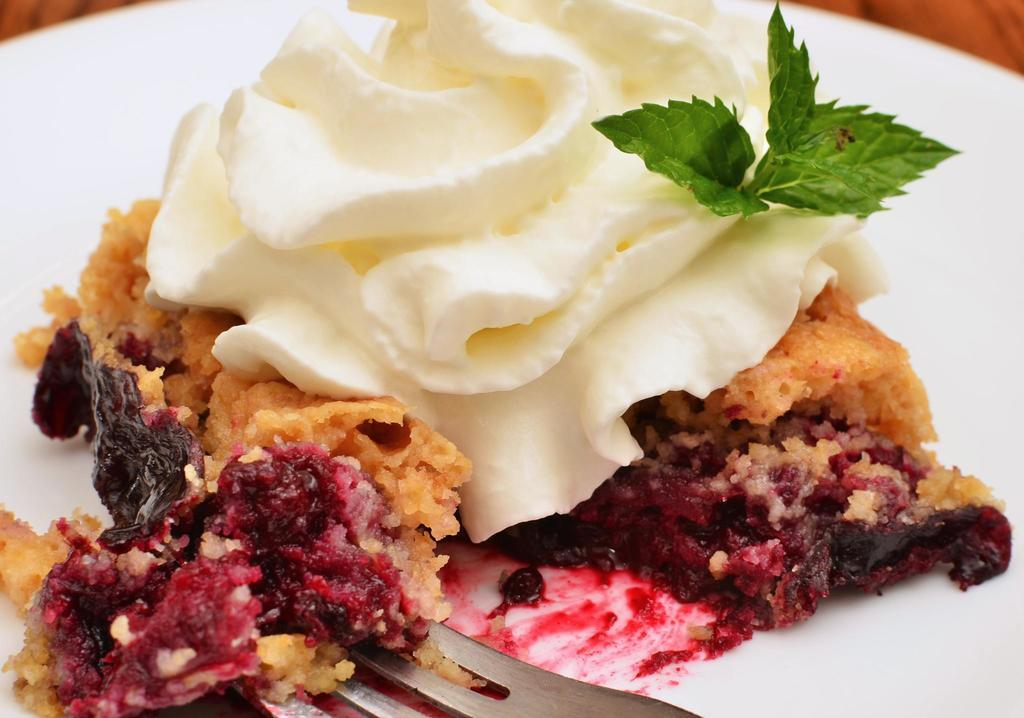What is the color of the plate in the image? The plate in the image is white. What is on the plate? There are different types of food on the plate. Can you describe the colors of the food on the plate? The food on the plate has colors such as cream, red, white, and green. Is there a heart-shaped box on the plate in the image? There is no box, heart-shaped or otherwise, present on the plate in the image. 